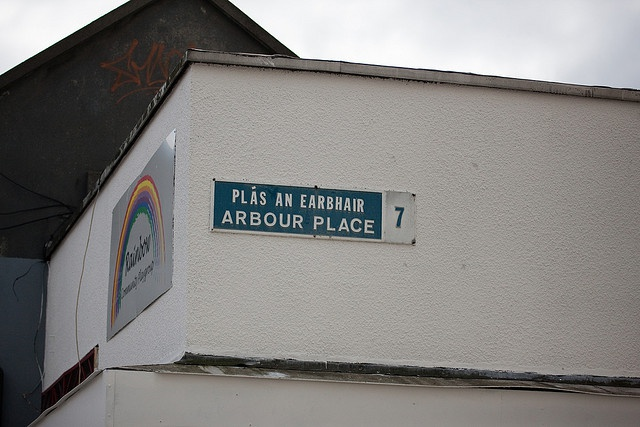Describe the objects in this image and their specific colors. I can see various objects in this image with different colors. 